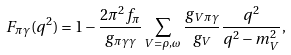<formula> <loc_0><loc_0><loc_500><loc_500>F _ { \pi \gamma } ( q ^ { 2 } ) = 1 - \frac { 2 \pi ^ { 2 } f _ { \pi } } { g _ { \pi \gamma \gamma } } \sum _ { V = \rho , \omega } \frac { g _ { V \pi \gamma } } { g _ { V } } \frac { q ^ { 2 } } { q ^ { 2 } - m _ { V } ^ { 2 } } ,</formula> 